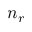<formula> <loc_0><loc_0><loc_500><loc_500>n _ { r }</formula> 